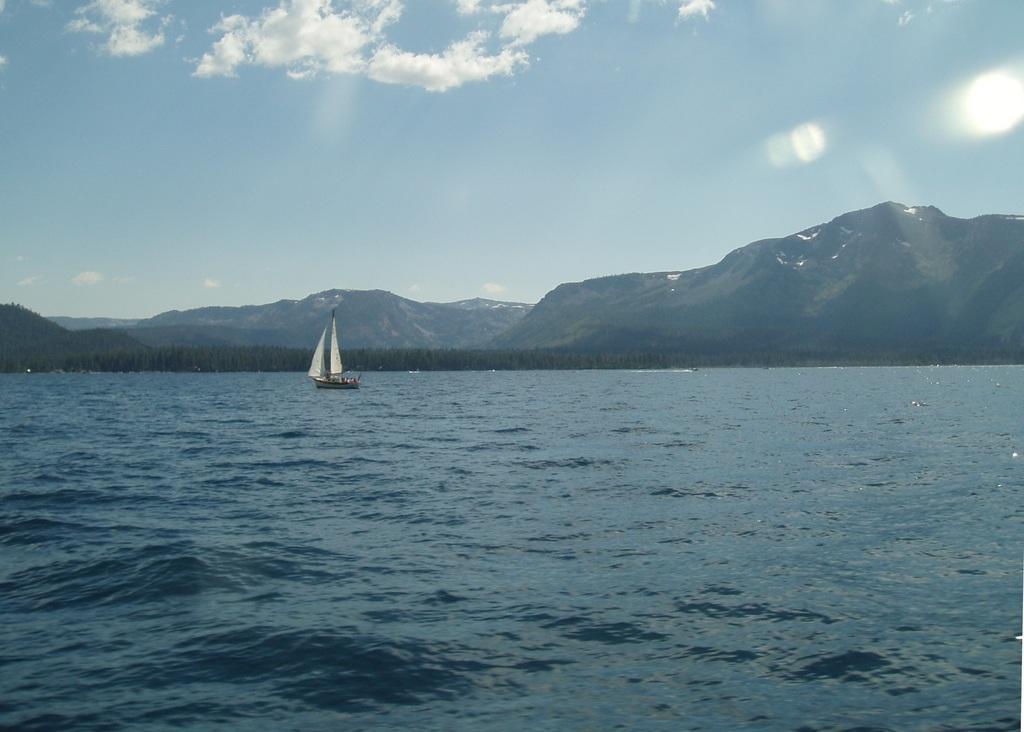How would you summarize this image in a sentence or two? In this picture I can observe an ocean. There is a boat floating on the water on the left side. In the background I can observe hills and some clouds in the sky. 